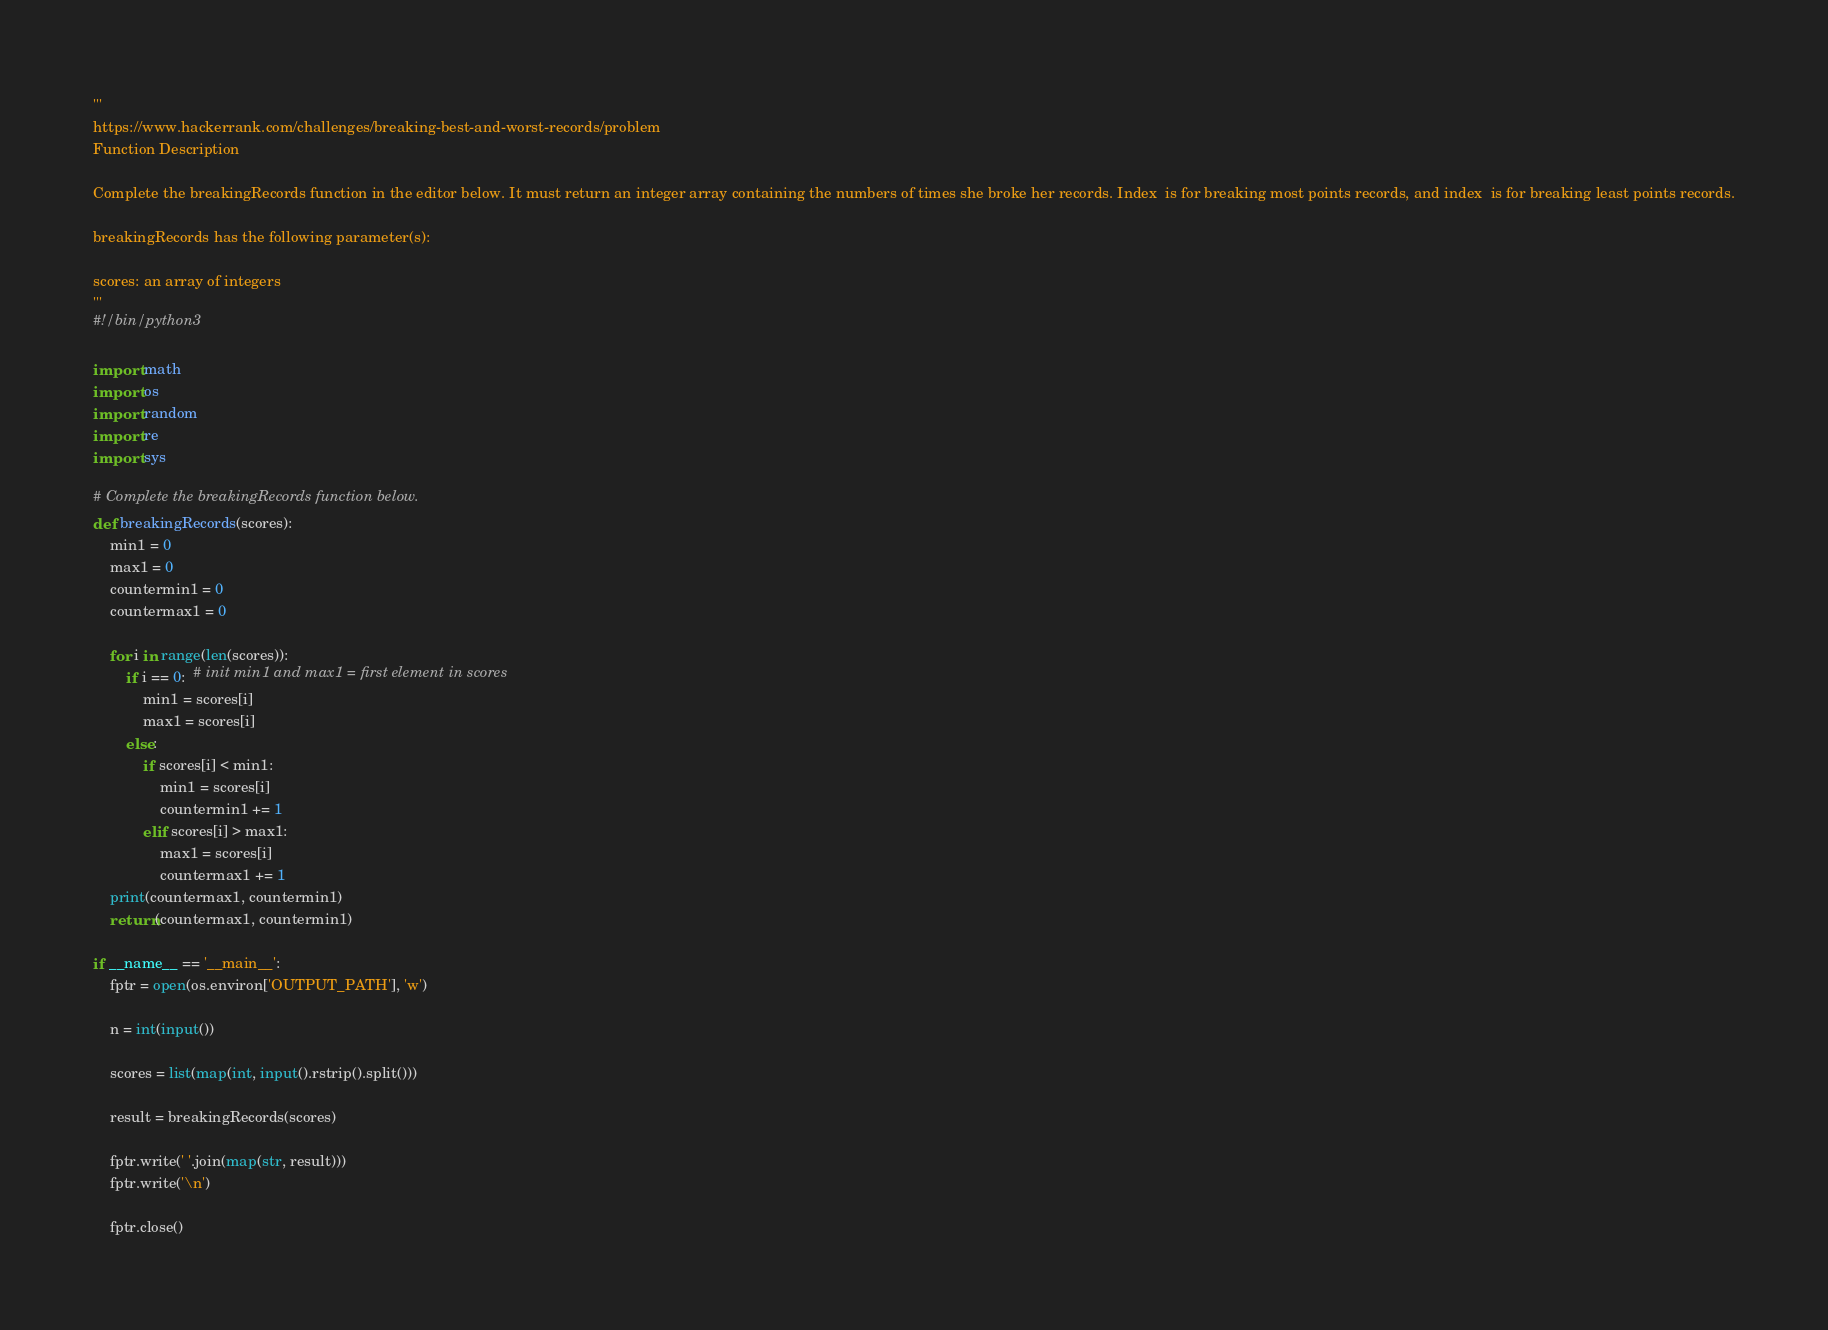Convert code to text. <code><loc_0><loc_0><loc_500><loc_500><_Python_>'''
https://www.hackerrank.com/challenges/breaking-best-and-worst-records/problem
Function Description

Complete the breakingRecords function in the editor below. It must return an integer array containing the numbers of times she broke her records. Index  is for breaking most points records, and index  is for breaking least points records.

breakingRecords has the following parameter(s):

scores: an array of integers
'''
#!/bin/python3

import math
import os
import random
import re
import sys

# Complete the breakingRecords function below.
def breakingRecords(scores):
    min1 = 0
    max1 = 0
    countermin1 = 0
    countermax1 = 0

    for i in range(len(scores)):
        if i == 0:  # init min1 and max1 = first element in scores
            min1 = scores[i]
            max1 = scores[i]
        else:
            if scores[i] < min1:
                min1 = scores[i]
                countermin1 += 1
            elif scores[i] > max1:
                max1 = scores[i]
                countermax1 += 1
    print(countermax1, countermin1)
    return(countermax1, countermin1)

if __name__ == '__main__':
    fptr = open(os.environ['OUTPUT_PATH'], 'w')

    n = int(input())

    scores = list(map(int, input().rstrip().split()))

    result = breakingRecords(scores)

    fptr.write(' '.join(map(str, result)))
    fptr.write('\n')

    fptr.close()
</code> 